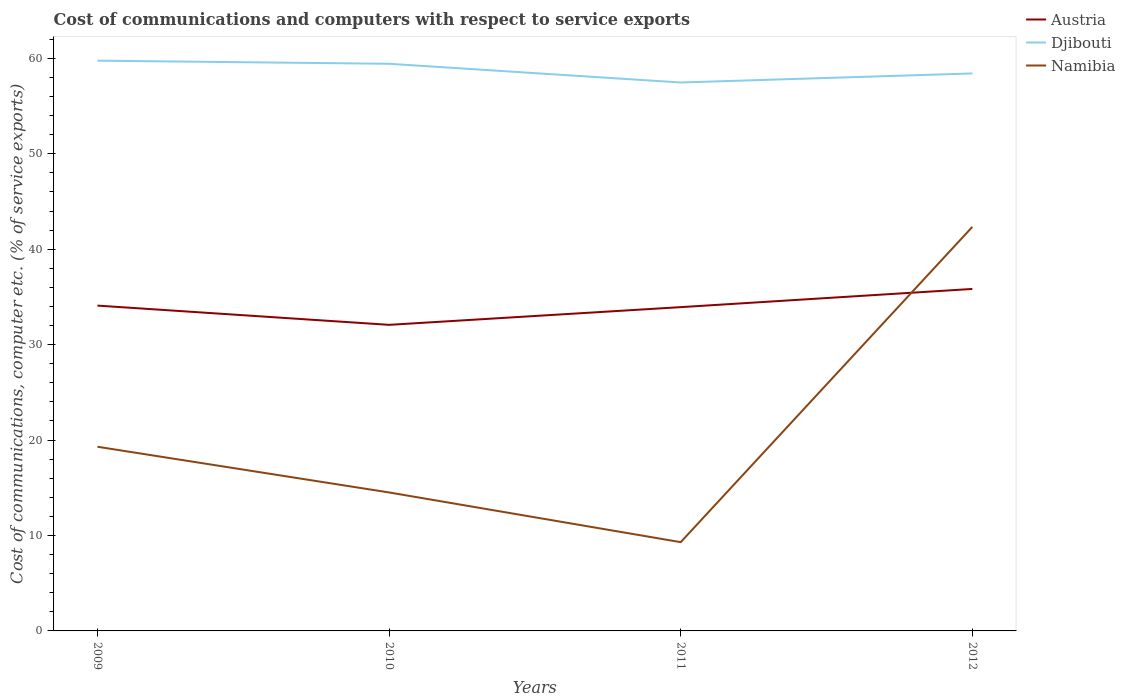Across all years, what is the maximum cost of communications and computers in Austria?
Give a very brief answer. 32.07. What is the total cost of communications and computers in Austria in the graph?
Offer a very short reply. -1.86. What is the difference between the highest and the second highest cost of communications and computers in Austria?
Offer a very short reply. 3.76. Is the cost of communications and computers in Namibia strictly greater than the cost of communications and computers in Austria over the years?
Offer a very short reply. No. How many lines are there?
Provide a short and direct response. 3. Where does the legend appear in the graph?
Your answer should be compact. Top right. How many legend labels are there?
Give a very brief answer. 3. How are the legend labels stacked?
Provide a succinct answer. Vertical. What is the title of the graph?
Offer a terse response. Cost of communications and computers with respect to service exports. Does "Jamaica" appear as one of the legend labels in the graph?
Your response must be concise. No. What is the label or title of the Y-axis?
Offer a very short reply. Cost of communications, computer etc. (% of service exports). What is the Cost of communications, computer etc. (% of service exports) in Austria in 2009?
Ensure brevity in your answer.  34.09. What is the Cost of communications, computer etc. (% of service exports) of Djibouti in 2009?
Your answer should be compact. 59.75. What is the Cost of communications, computer etc. (% of service exports) of Namibia in 2009?
Offer a very short reply. 19.3. What is the Cost of communications, computer etc. (% of service exports) in Austria in 2010?
Keep it short and to the point. 32.07. What is the Cost of communications, computer etc. (% of service exports) of Djibouti in 2010?
Give a very brief answer. 59.43. What is the Cost of communications, computer etc. (% of service exports) in Namibia in 2010?
Give a very brief answer. 14.51. What is the Cost of communications, computer etc. (% of service exports) of Austria in 2011?
Provide a succinct answer. 33.93. What is the Cost of communications, computer etc. (% of service exports) of Djibouti in 2011?
Your answer should be very brief. 57.47. What is the Cost of communications, computer etc. (% of service exports) in Namibia in 2011?
Provide a succinct answer. 9.3. What is the Cost of communications, computer etc. (% of service exports) of Austria in 2012?
Provide a short and direct response. 35.83. What is the Cost of communications, computer etc. (% of service exports) of Djibouti in 2012?
Provide a succinct answer. 58.42. What is the Cost of communications, computer etc. (% of service exports) of Namibia in 2012?
Provide a short and direct response. 42.34. Across all years, what is the maximum Cost of communications, computer etc. (% of service exports) of Austria?
Provide a short and direct response. 35.83. Across all years, what is the maximum Cost of communications, computer etc. (% of service exports) of Djibouti?
Keep it short and to the point. 59.75. Across all years, what is the maximum Cost of communications, computer etc. (% of service exports) in Namibia?
Keep it short and to the point. 42.34. Across all years, what is the minimum Cost of communications, computer etc. (% of service exports) of Austria?
Give a very brief answer. 32.07. Across all years, what is the minimum Cost of communications, computer etc. (% of service exports) of Djibouti?
Your response must be concise. 57.47. Across all years, what is the minimum Cost of communications, computer etc. (% of service exports) of Namibia?
Your answer should be compact. 9.3. What is the total Cost of communications, computer etc. (% of service exports) of Austria in the graph?
Provide a succinct answer. 135.92. What is the total Cost of communications, computer etc. (% of service exports) of Djibouti in the graph?
Offer a very short reply. 235.06. What is the total Cost of communications, computer etc. (% of service exports) of Namibia in the graph?
Your answer should be very brief. 85.45. What is the difference between the Cost of communications, computer etc. (% of service exports) in Austria in 2009 and that in 2010?
Provide a succinct answer. 2.02. What is the difference between the Cost of communications, computer etc. (% of service exports) of Djibouti in 2009 and that in 2010?
Ensure brevity in your answer.  0.33. What is the difference between the Cost of communications, computer etc. (% of service exports) in Namibia in 2009 and that in 2010?
Your answer should be compact. 4.79. What is the difference between the Cost of communications, computer etc. (% of service exports) of Austria in 2009 and that in 2011?
Provide a short and direct response. 0.16. What is the difference between the Cost of communications, computer etc. (% of service exports) of Djibouti in 2009 and that in 2011?
Provide a short and direct response. 2.29. What is the difference between the Cost of communications, computer etc. (% of service exports) in Namibia in 2009 and that in 2011?
Your answer should be compact. 10. What is the difference between the Cost of communications, computer etc. (% of service exports) of Austria in 2009 and that in 2012?
Offer a terse response. -1.75. What is the difference between the Cost of communications, computer etc. (% of service exports) of Djibouti in 2009 and that in 2012?
Keep it short and to the point. 1.34. What is the difference between the Cost of communications, computer etc. (% of service exports) in Namibia in 2009 and that in 2012?
Give a very brief answer. -23.04. What is the difference between the Cost of communications, computer etc. (% of service exports) in Austria in 2010 and that in 2011?
Your answer should be very brief. -1.86. What is the difference between the Cost of communications, computer etc. (% of service exports) in Djibouti in 2010 and that in 2011?
Your response must be concise. 1.96. What is the difference between the Cost of communications, computer etc. (% of service exports) of Namibia in 2010 and that in 2011?
Give a very brief answer. 5.21. What is the difference between the Cost of communications, computer etc. (% of service exports) in Austria in 2010 and that in 2012?
Your answer should be very brief. -3.76. What is the difference between the Cost of communications, computer etc. (% of service exports) in Djibouti in 2010 and that in 2012?
Keep it short and to the point. 1.01. What is the difference between the Cost of communications, computer etc. (% of service exports) in Namibia in 2010 and that in 2012?
Keep it short and to the point. -27.83. What is the difference between the Cost of communications, computer etc. (% of service exports) of Austria in 2011 and that in 2012?
Keep it short and to the point. -1.91. What is the difference between the Cost of communications, computer etc. (% of service exports) of Djibouti in 2011 and that in 2012?
Provide a succinct answer. -0.95. What is the difference between the Cost of communications, computer etc. (% of service exports) in Namibia in 2011 and that in 2012?
Offer a very short reply. -33.04. What is the difference between the Cost of communications, computer etc. (% of service exports) in Austria in 2009 and the Cost of communications, computer etc. (% of service exports) in Djibouti in 2010?
Your answer should be compact. -25.34. What is the difference between the Cost of communications, computer etc. (% of service exports) of Austria in 2009 and the Cost of communications, computer etc. (% of service exports) of Namibia in 2010?
Keep it short and to the point. 19.58. What is the difference between the Cost of communications, computer etc. (% of service exports) of Djibouti in 2009 and the Cost of communications, computer etc. (% of service exports) of Namibia in 2010?
Provide a succinct answer. 45.25. What is the difference between the Cost of communications, computer etc. (% of service exports) in Austria in 2009 and the Cost of communications, computer etc. (% of service exports) in Djibouti in 2011?
Make the answer very short. -23.38. What is the difference between the Cost of communications, computer etc. (% of service exports) in Austria in 2009 and the Cost of communications, computer etc. (% of service exports) in Namibia in 2011?
Make the answer very short. 24.79. What is the difference between the Cost of communications, computer etc. (% of service exports) of Djibouti in 2009 and the Cost of communications, computer etc. (% of service exports) of Namibia in 2011?
Give a very brief answer. 50.45. What is the difference between the Cost of communications, computer etc. (% of service exports) of Austria in 2009 and the Cost of communications, computer etc. (% of service exports) of Djibouti in 2012?
Offer a terse response. -24.33. What is the difference between the Cost of communications, computer etc. (% of service exports) of Austria in 2009 and the Cost of communications, computer etc. (% of service exports) of Namibia in 2012?
Your answer should be very brief. -8.25. What is the difference between the Cost of communications, computer etc. (% of service exports) of Djibouti in 2009 and the Cost of communications, computer etc. (% of service exports) of Namibia in 2012?
Give a very brief answer. 17.42. What is the difference between the Cost of communications, computer etc. (% of service exports) in Austria in 2010 and the Cost of communications, computer etc. (% of service exports) in Djibouti in 2011?
Provide a succinct answer. -25.39. What is the difference between the Cost of communications, computer etc. (% of service exports) in Austria in 2010 and the Cost of communications, computer etc. (% of service exports) in Namibia in 2011?
Provide a short and direct response. 22.77. What is the difference between the Cost of communications, computer etc. (% of service exports) of Djibouti in 2010 and the Cost of communications, computer etc. (% of service exports) of Namibia in 2011?
Offer a very short reply. 50.13. What is the difference between the Cost of communications, computer etc. (% of service exports) of Austria in 2010 and the Cost of communications, computer etc. (% of service exports) of Djibouti in 2012?
Your answer should be very brief. -26.34. What is the difference between the Cost of communications, computer etc. (% of service exports) in Austria in 2010 and the Cost of communications, computer etc. (% of service exports) in Namibia in 2012?
Your answer should be compact. -10.27. What is the difference between the Cost of communications, computer etc. (% of service exports) of Djibouti in 2010 and the Cost of communications, computer etc. (% of service exports) of Namibia in 2012?
Your answer should be very brief. 17.09. What is the difference between the Cost of communications, computer etc. (% of service exports) in Austria in 2011 and the Cost of communications, computer etc. (% of service exports) in Djibouti in 2012?
Your response must be concise. -24.49. What is the difference between the Cost of communications, computer etc. (% of service exports) of Austria in 2011 and the Cost of communications, computer etc. (% of service exports) of Namibia in 2012?
Provide a short and direct response. -8.41. What is the difference between the Cost of communications, computer etc. (% of service exports) of Djibouti in 2011 and the Cost of communications, computer etc. (% of service exports) of Namibia in 2012?
Offer a terse response. 15.13. What is the average Cost of communications, computer etc. (% of service exports) in Austria per year?
Your answer should be compact. 33.98. What is the average Cost of communications, computer etc. (% of service exports) in Djibouti per year?
Offer a very short reply. 58.77. What is the average Cost of communications, computer etc. (% of service exports) of Namibia per year?
Your answer should be compact. 21.36. In the year 2009, what is the difference between the Cost of communications, computer etc. (% of service exports) of Austria and Cost of communications, computer etc. (% of service exports) of Djibouti?
Provide a short and direct response. -25.67. In the year 2009, what is the difference between the Cost of communications, computer etc. (% of service exports) of Austria and Cost of communications, computer etc. (% of service exports) of Namibia?
Make the answer very short. 14.79. In the year 2009, what is the difference between the Cost of communications, computer etc. (% of service exports) in Djibouti and Cost of communications, computer etc. (% of service exports) in Namibia?
Provide a short and direct response. 40.46. In the year 2010, what is the difference between the Cost of communications, computer etc. (% of service exports) of Austria and Cost of communications, computer etc. (% of service exports) of Djibouti?
Ensure brevity in your answer.  -27.35. In the year 2010, what is the difference between the Cost of communications, computer etc. (% of service exports) of Austria and Cost of communications, computer etc. (% of service exports) of Namibia?
Your answer should be compact. 17.56. In the year 2010, what is the difference between the Cost of communications, computer etc. (% of service exports) in Djibouti and Cost of communications, computer etc. (% of service exports) in Namibia?
Ensure brevity in your answer.  44.92. In the year 2011, what is the difference between the Cost of communications, computer etc. (% of service exports) in Austria and Cost of communications, computer etc. (% of service exports) in Djibouti?
Offer a very short reply. -23.54. In the year 2011, what is the difference between the Cost of communications, computer etc. (% of service exports) in Austria and Cost of communications, computer etc. (% of service exports) in Namibia?
Offer a terse response. 24.63. In the year 2011, what is the difference between the Cost of communications, computer etc. (% of service exports) in Djibouti and Cost of communications, computer etc. (% of service exports) in Namibia?
Offer a very short reply. 48.16. In the year 2012, what is the difference between the Cost of communications, computer etc. (% of service exports) in Austria and Cost of communications, computer etc. (% of service exports) in Djibouti?
Ensure brevity in your answer.  -22.58. In the year 2012, what is the difference between the Cost of communications, computer etc. (% of service exports) in Austria and Cost of communications, computer etc. (% of service exports) in Namibia?
Offer a very short reply. -6.5. In the year 2012, what is the difference between the Cost of communications, computer etc. (% of service exports) of Djibouti and Cost of communications, computer etc. (% of service exports) of Namibia?
Provide a short and direct response. 16.08. What is the ratio of the Cost of communications, computer etc. (% of service exports) of Austria in 2009 to that in 2010?
Ensure brevity in your answer.  1.06. What is the ratio of the Cost of communications, computer etc. (% of service exports) of Namibia in 2009 to that in 2010?
Offer a very short reply. 1.33. What is the ratio of the Cost of communications, computer etc. (% of service exports) in Djibouti in 2009 to that in 2011?
Offer a very short reply. 1.04. What is the ratio of the Cost of communications, computer etc. (% of service exports) in Namibia in 2009 to that in 2011?
Ensure brevity in your answer.  2.07. What is the ratio of the Cost of communications, computer etc. (% of service exports) in Austria in 2009 to that in 2012?
Keep it short and to the point. 0.95. What is the ratio of the Cost of communications, computer etc. (% of service exports) of Djibouti in 2009 to that in 2012?
Provide a short and direct response. 1.02. What is the ratio of the Cost of communications, computer etc. (% of service exports) in Namibia in 2009 to that in 2012?
Offer a terse response. 0.46. What is the ratio of the Cost of communications, computer etc. (% of service exports) of Austria in 2010 to that in 2011?
Offer a terse response. 0.95. What is the ratio of the Cost of communications, computer etc. (% of service exports) in Djibouti in 2010 to that in 2011?
Give a very brief answer. 1.03. What is the ratio of the Cost of communications, computer etc. (% of service exports) in Namibia in 2010 to that in 2011?
Your answer should be very brief. 1.56. What is the ratio of the Cost of communications, computer etc. (% of service exports) of Austria in 2010 to that in 2012?
Your response must be concise. 0.9. What is the ratio of the Cost of communications, computer etc. (% of service exports) of Djibouti in 2010 to that in 2012?
Provide a short and direct response. 1.02. What is the ratio of the Cost of communications, computer etc. (% of service exports) in Namibia in 2010 to that in 2012?
Your answer should be compact. 0.34. What is the ratio of the Cost of communications, computer etc. (% of service exports) of Austria in 2011 to that in 2012?
Ensure brevity in your answer.  0.95. What is the ratio of the Cost of communications, computer etc. (% of service exports) of Djibouti in 2011 to that in 2012?
Provide a succinct answer. 0.98. What is the ratio of the Cost of communications, computer etc. (% of service exports) in Namibia in 2011 to that in 2012?
Keep it short and to the point. 0.22. What is the difference between the highest and the second highest Cost of communications, computer etc. (% of service exports) of Austria?
Keep it short and to the point. 1.75. What is the difference between the highest and the second highest Cost of communications, computer etc. (% of service exports) in Djibouti?
Offer a very short reply. 0.33. What is the difference between the highest and the second highest Cost of communications, computer etc. (% of service exports) of Namibia?
Provide a succinct answer. 23.04. What is the difference between the highest and the lowest Cost of communications, computer etc. (% of service exports) in Austria?
Provide a short and direct response. 3.76. What is the difference between the highest and the lowest Cost of communications, computer etc. (% of service exports) of Djibouti?
Ensure brevity in your answer.  2.29. What is the difference between the highest and the lowest Cost of communications, computer etc. (% of service exports) of Namibia?
Keep it short and to the point. 33.04. 